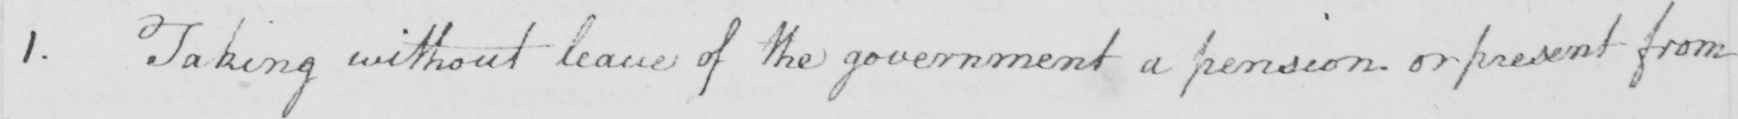Can you tell me what this handwritten text says? 1 . Taking without leave of the government a pension or present from 